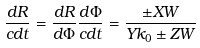Convert formula to latex. <formula><loc_0><loc_0><loc_500><loc_500>\frac { d R } { c d t } = \frac { d R } { d \Phi } \frac { d \Phi } { c d t } = \frac { \pm X W } { Y k _ { 0 } \pm Z W }</formula> 